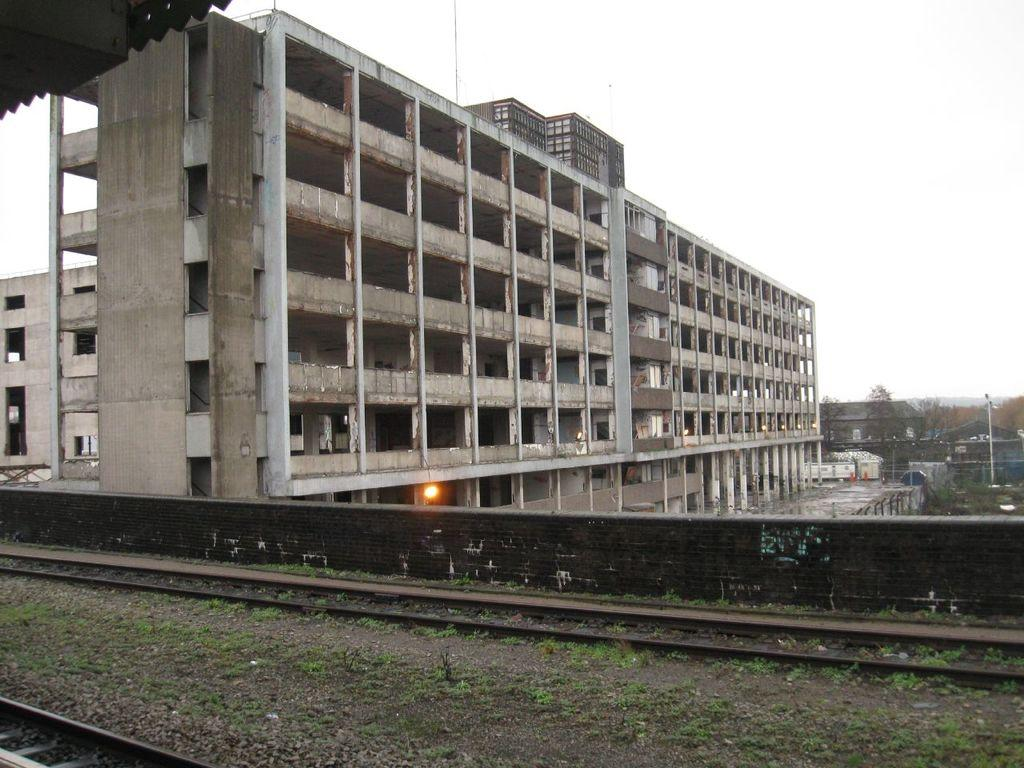What can be seen at the front of the image? There are railway tracks in the front of the image. What is located in the center of the image? There is a wall in the center of the image. What is visible in the background of the image? There is a fence, buildings, and trees in the background of the image. Where is the camera placed in the image? There is no camera present in the image. Who is the expert in the image? There is no expert depicted in the image. 